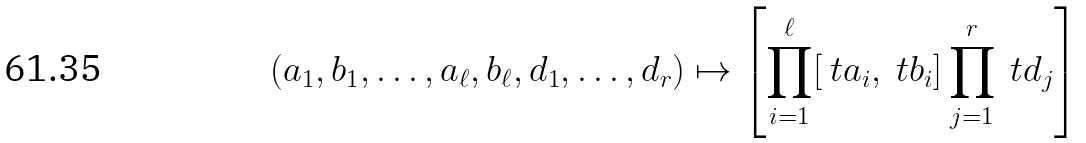<formula> <loc_0><loc_0><loc_500><loc_500>( a _ { 1 } , b _ { 1 } , \dots , a _ { \ell } , b _ { \ell } , d _ { 1 } , \dots , d _ { r } ) \mapsto \left [ \prod _ { i = 1 } ^ { \ell } [ \ t a _ { i } , \ t b _ { i } ] \prod _ { j = 1 } ^ { r } \ t d _ { j } \right ]</formula> 